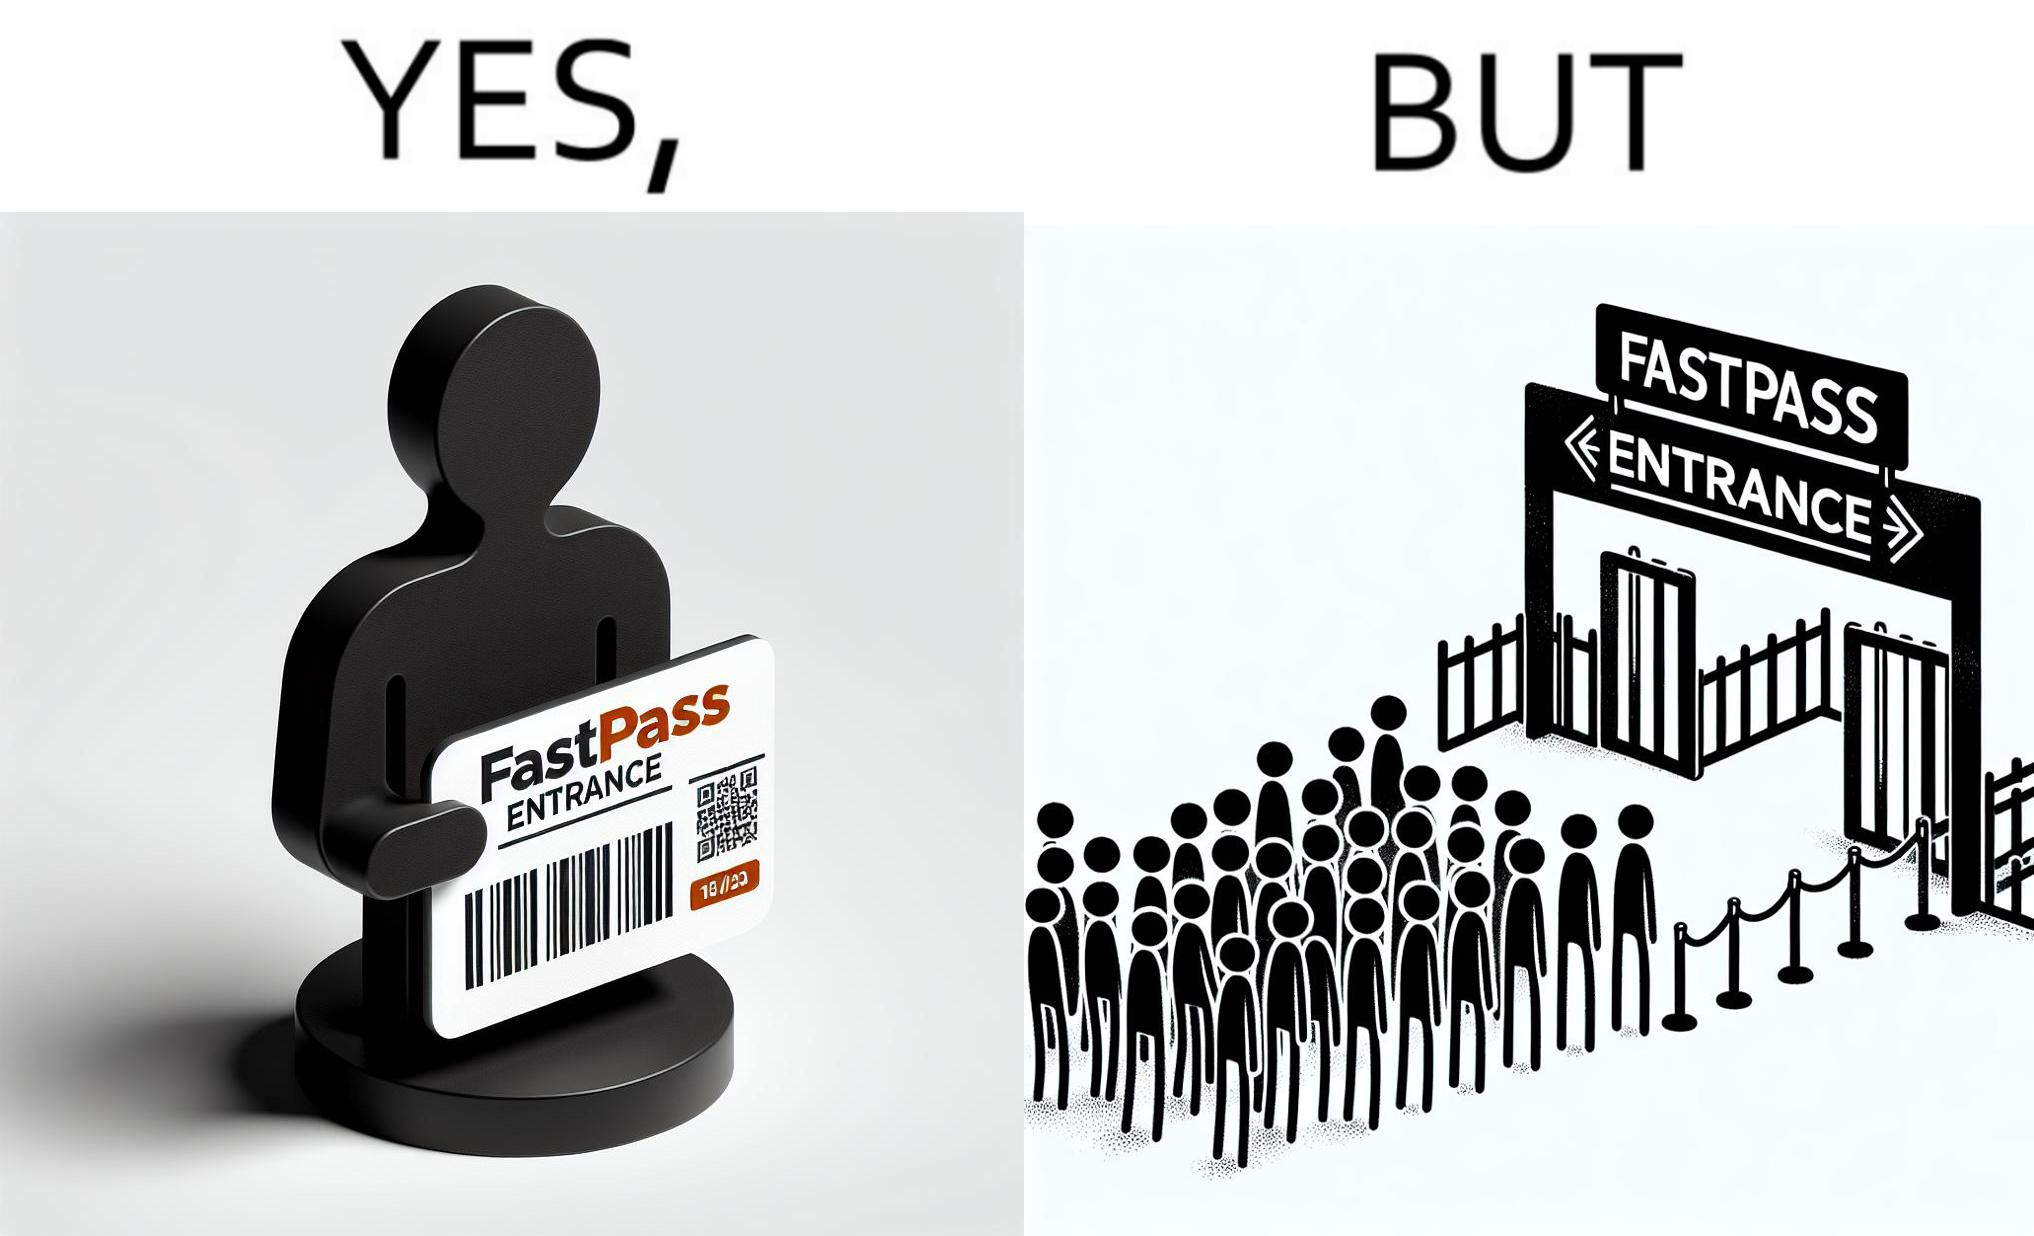Is this a satirical image? Yes, this image is satirical. 